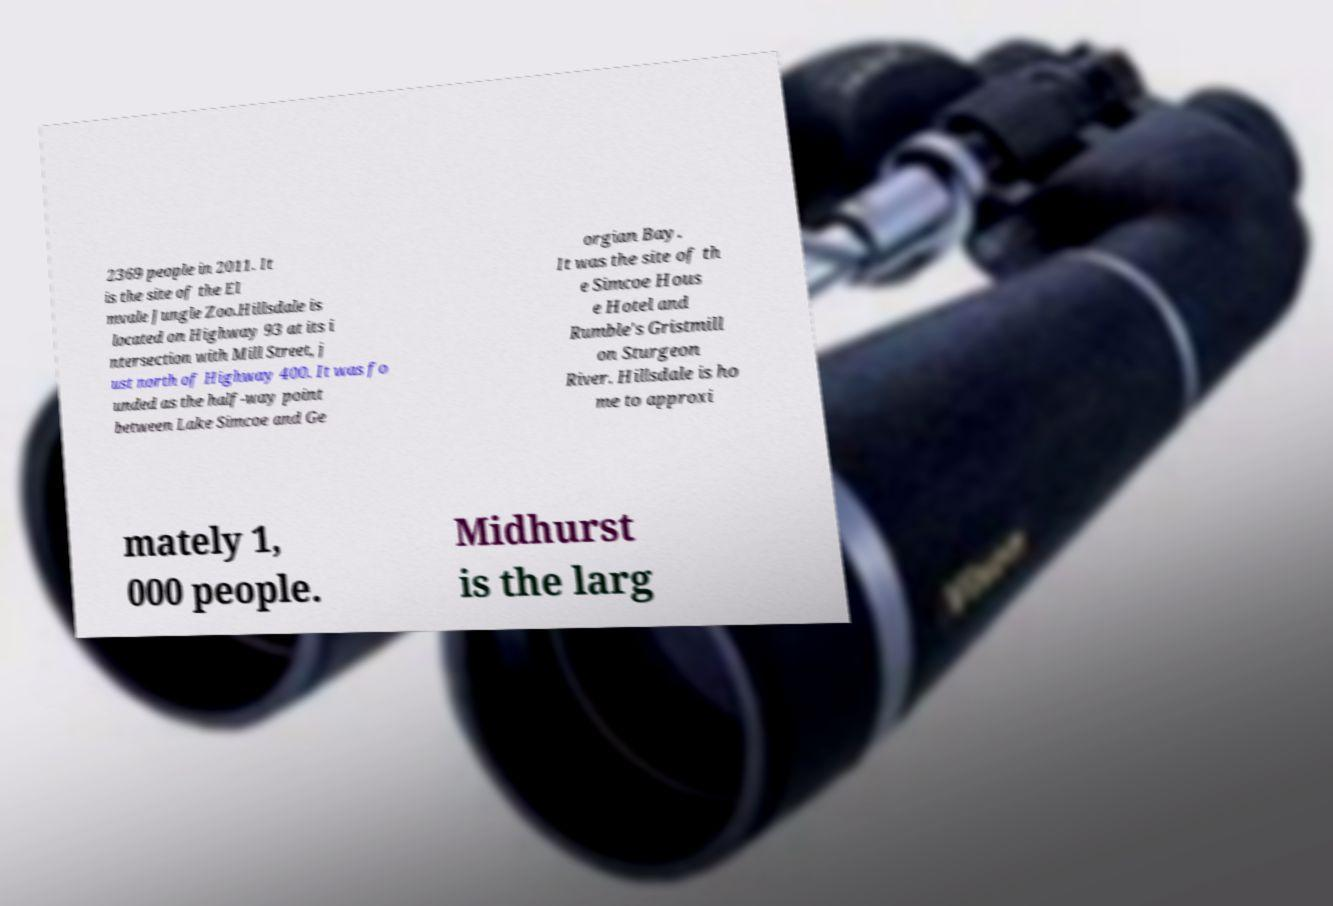Can you read and provide the text displayed in the image?This photo seems to have some interesting text. Can you extract and type it out for me? 2369 people in 2011. It is the site of the El mvale Jungle Zoo.Hillsdale is located on Highway 93 at its i ntersection with Mill Street, j ust north of Highway 400. It was fo unded as the half-way point between Lake Simcoe and Ge orgian Bay. It was the site of th e Simcoe Hous e Hotel and Rumble's Gristmill on Sturgeon River. Hillsdale is ho me to approxi mately 1, 000 people. Midhurst is the larg 